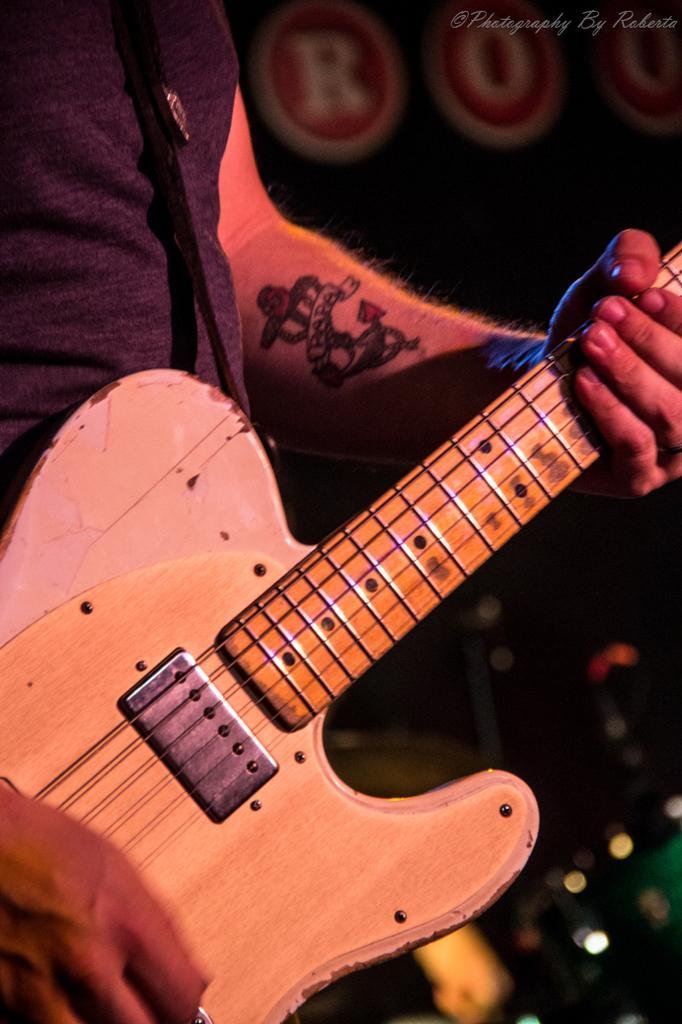Can you describe this image briefly? Here we can see a person holding a guitar and playing a guitar and he is having a tattoo on his hand 